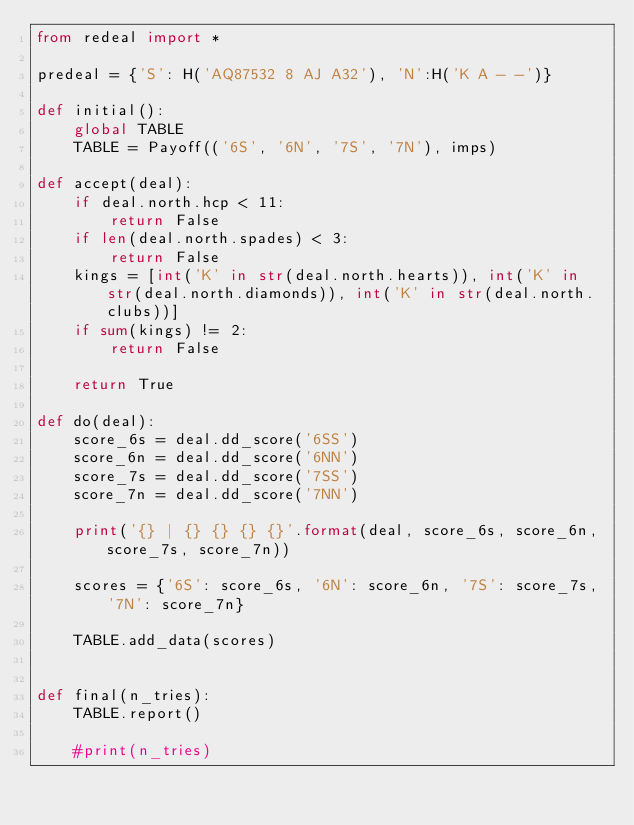Convert code to text. <code><loc_0><loc_0><loc_500><loc_500><_Python_>from redeal import *

predeal = {'S': H('AQ87532 8 AJ A32'), 'N':H('K A - -')}

def initial():
    global TABLE
    TABLE = Payoff(('6S', '6N', '7S', '7N'), imps)

def accept(deal):
    if deal.north.hcp < 11:
        return False
    if len(deal.north.spades) < 3:
        return False
    kings = [int('K' in str(deal.north.hearts)), int('K' in str(deal.north.diamonds)), int('K' in str(deal.north.clubs))]
    if sum(kings) != 2:
        return False

    return True

def do(deal):
    score_6s = deal.dd_score('6SS')
    score_6n = deal.dd_score('6NN')
    score_7s = deal.dd_score('7SS')
    score_7n = deal.dd_score('7NN')

    print('{} | {} {} {} {}'.format(deal, score_6s, score_6n, score_7s, score_7n))

    scores = {'6S': score_6s, '6N': score_6n, '7S': score_7s, '7N': score_7n}

    TABLE.add_data(scores)


def final(n_tries):
    TABLE.report()

    #print(n_tries)</code> 